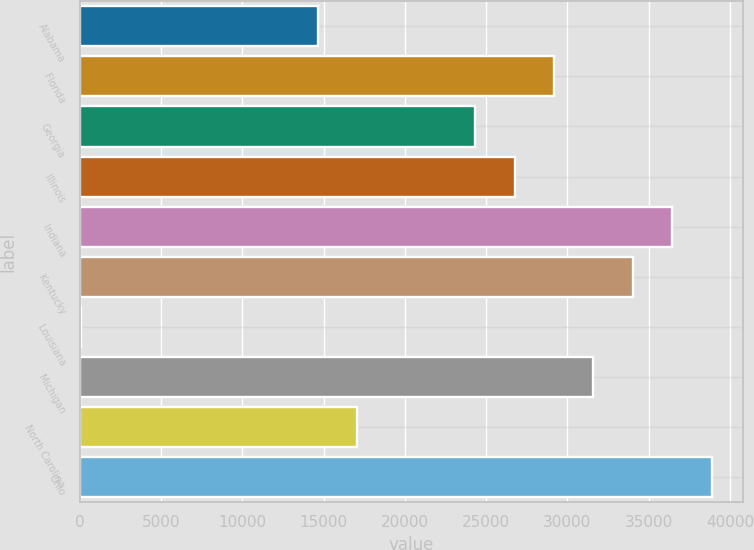Convert chart. <chart><loc_0><loc_0><loc_500><loc_500><bar_chart><fcel>Alabama<fcel>Florida<fcel>Georgia<fcel>Illinois<fcel>Indiana<fcel>Kentucky<fcel>Louisiana<fcel>Michigan<fcel>North Carolina<fcel>Ohio<nl><fcel>14630<fcel>29171<fcel>24324<fcel>26747.5<fcel>36441.5<fcel>34018<fcel>89<fcel>31594.5<fcel>17053.5<fcel>38865<nl></chart> 